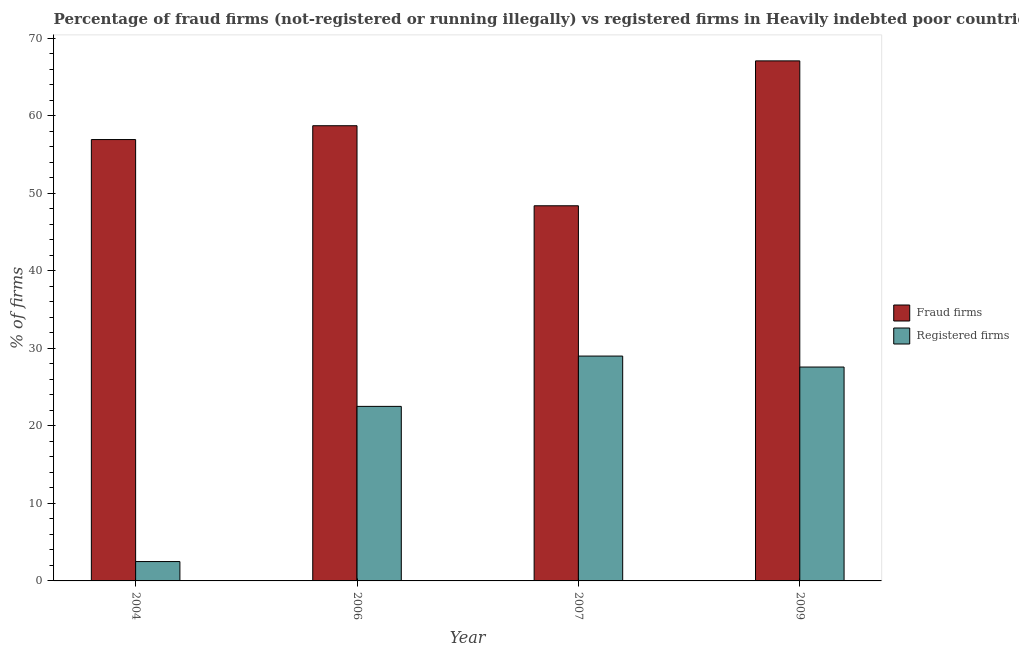How many bars are there on the 3rd tick from the left?
Your answer should be compact. 2. How many bars are there on the 3rd tick from the right?
Provide a short and direct response. 2. In how many cases, is the number of bars for a given year not equal to the number of legend labels?
Keep it short and to the point. 0. What is the percentage of registered firms in 2006?
Your response must be concise. 22.52. Across all years, what is the maximum percentage of fraud firms?
Your answer should be compact. 67.11. In which year was the percentage of fraud firms maximum?
Offer a terse response. 2009. In which year was the percentage of registered firms minimum?
Your answer should be compact. 2004. What is the total percentage of registered firms in the graph?
Your answer should be very brief. 81.64. What is the difference between the percentage of registered firms in 2004 and that in 2009?
Offer a terse response. -25.1. What is the difference between the percentage of fraud firms in 2009 and the percentage of registered firms in 2007?
Your response must be concise. 18.7. What is the average percentage of fraud firms per year?
Make the answer very short. 57.8. What is the ratio of the percentage of fraud firms in 2004 to that in 2006?
Provide a succinct answer. 0.97. Is the percentage of registered firms in 2006 less than that in 2007?
Give a very brief answer. Yes. What is the difference between the highest and the second highest percentage of registered firms?
Give a very brief answer. 1.42. What is the difference between the highest and the lowest percentage of registered firms?
Ensure brevity in your answer.  26.52. In how many years, is the percentage of fraud firms greater than the average percentage of fraud firms taken over all years?
Keep it short and to the point. 2. What does the 2nd bar from the left in 2004 represents?
Keep it short and to the point. Registered firms. What does the 2nd bar from the right in 2004 represents?
Your answer should be very brief. Fraud firms. How many years are there in the graph?
Provide a short and direct response. 4. What is the difference between two consecutive major ticks on the Y-axis?
Ensure brevity in your answer.  10. Are the values on the major ticks of Y-axis written in scientific E-notation?
Make the answer very short. No. Does the graph contain any zero values?
Make the answer very short. No. Where does the legend appear in the graph?
Provide a succinct answer. Center right. How many legend labels are there?
Offer a very short reply. 2. What is the title of the graph?
Ensure brevity in your answer.  Percentage of fraud firms (not-registered or running illegally) vs registered firms in Heavily indebted poor countries. What is the label or title of the Y-axis?
Provide a succinct answer. % of firms. What is the % of firms of Fraud firms in 2004?
Keep it short and to the point. 56.95. What is the % of firms in Registered firms in 2004?
Offer a terse response. 2.5. What is the % of firms of Fraud firms in 2006?
Ensure brevity in your answer.  58.74. What is the % of firms in Registered firms in 2006?
Your response must be concise. 22.52. What is the % of firms of Fraud firms in 2007?
Your answer should be compact. 48.41. What is the % of firms in Registered firms in 2007?
Your answer should be very brief. 29.02. What is the % of firms in Fraud firms in 2009?
Your response must be concise. 67.11. What is the % of firms in Registered firms in 2009?
Your answer should be very brief. 27.6. Across all years, what is the maximum % of firms in Fraud firms?
Ensure brevity in your answer.  67.11. Across all years, what is the maximum % of firms in Registered firms?
Provide a succinct answer. 29.02. Across all years, what is the minimum % of firms of Fraud firms?
Give a very brief answer. 48.41. What is the total % of firms in Fraud firms in the graph?
Keep it short and to the point. 231.21. What is the total % of firms of Registered firms in the graph?
Keep it short and to the point. 81.64. What is the difference between the % of firms in Fraud firms in 2004 and that in 2006?
Provide a succinct answer. -1.79. What is the difference between the % of firms of Registered firms in 2004 and that in 2006?
Your answer should be compact. -20.02. What is the difference between the % of firms in Fraud firms in 2004 and that in 2007?
Your answer should be compact. 8.54. What is the difference between the % of firms of Registered firms in 2004 and that in 2007?
Provide a succinct answer. -26.52. What is the difference between the % of firms of Fraud firms in 2004 and that in 2009?
Ensure brevity in your answer.  -10.15. What is the difference between the % of firms of Registered firms in 2004 and that in 2009?
Your response must be concise. -25.1. What is the difference between the % of firms of Fraud firms in 2006 and that in 2007?
Offer a terse response. 10.33. What is the difference between the % of firms in Registered firms in 2006 and that in 2007?
Keep it short and to the point. -6.49. What is the difference between the % of firms in Fraud firms in 2006 and that in 2009?
Keep it short and to the point. -8.37. What is the difference between the % of firms of Registered firms in 2006 and that in 2009?
Provide a short and direct response. -5.08. What is the difference between the % of firms of Fraud firms in 2007 and that in 2009?
Your answer should be compact. -18.7. What is the difference between the % of firms of Registered firms in 2007 and that in 2009?
Offer a very short reply. 1.42. What is the difference between the % of firms in Fraud firms in 2004 and the % of firms in Registered firms in 2006?
Your answer should be very brief. 34.43. What is the difference between the % of firms of Fraud firms in 2004 and the % of firms of Registered firms in 2007?
Your answer should be compact. 27.94. What is the difference between the % of firms of Fraud firms in 2004 and the % of firms of Registered firms in 2009?
Offer a terse response. 29.36. What is the difference between the % of firms in Fraud firms in 2006 and the % of firms in Registered firms in 2007?
Make the answer very short. 29.72. What is the difference between the % of firms in Fraud firms in 2006 and the % of firms in Registered firms in 2009?
Your response must be concise. 31.14. What is the difference between the % of firms of Fraud firms in 2007 and the % of firms of Registered firms in 2009?
Your answer should be compact. 20.81. What is the average % of firms of Fraud firms per year?
Your answer should be very brief. 57.8. What is the average % of firms of Registered firms per year?
Provide a short and direct response. 20.41. In the year 2004, what is the difference between the % of firms in Fraud firms and % of firms in Registered firms?
Offer a terse response. 54.45. In the year 2006, what is the difference between the % of firms of Fraud firms and % of firms of Registered firms?
Provide a short and direct response. 36.22. In the year 2007, what is the difference between the % of firms of Fraud firms and % of firms of Registered firms?
Provide a succinct answer. 19.39. In the year 2009, what is the difference between the % of firms of Fraud firms and % of firms of Registered firms?
Keep it short and to the point. 39.51. What is the ratio of the % of firms of Fraud firms in 2004 to that in 2006?
Provide a succinct answer. 0.97. What is the ratio of the % of firms in Registered firms in 2004 to that in 2006?
Ensure brevity in your answer.  0.11. What is the ratio of the % of firms of Fraud firms in 2004 to that in 2007?
Provide a succinct answer. 1.18. What is the ratio of the % of firms of Registered firms in 2004 to that in 2007?
Ensure brevity in your answer.  0.09. What is the ratio of the % of firms of Fraud firms in 2004 to that in 2009?
Keep it short and to the point. 0.85. What is the ratio of the % of firms of Registered firms in 2004 to that in 2009?
Provide a succinct answer. 0.09. What is the ratio of the % of firms in Fraud firms in 2006 to that in 2007?
Offer a terse response. 1.21. What is the ratio of the % of firms in Registered firms in 2006 to that in 2007?
Offer a terse response. 0.78. What is the ratio of the % of firms in Fraud firms in 2006 to that in 2009?
Provide a short and direct response. 0.88. What is the ratio of the % of firms of Registered firms in 2006 to that in 2009?
Offer a very short reply. 0.82. What is the ratio of the % of firms in Fraud firms in 2007 to that in 2009?
Give a very brief answer. 0.72. What is the ratio of the % of firms of Registered firms in 2007 to that in 2009?
Your answer should be very brief. 1.05. What is the difference between the highest and the second highest % of firms in Fraud firms?
Make the answer very short. 8.37. What is the difference between the highest and the second highest % of firms of Registered firms?
Your answer should be compact. 1.42. What is the difference between the highest and the lowest % of firms in Fraud firms?
Provide a succinct answer. 18.7. What is the difference between the highest and the lowest % of firms of Registered firms?
Keep it short and to the point. 26.52. 